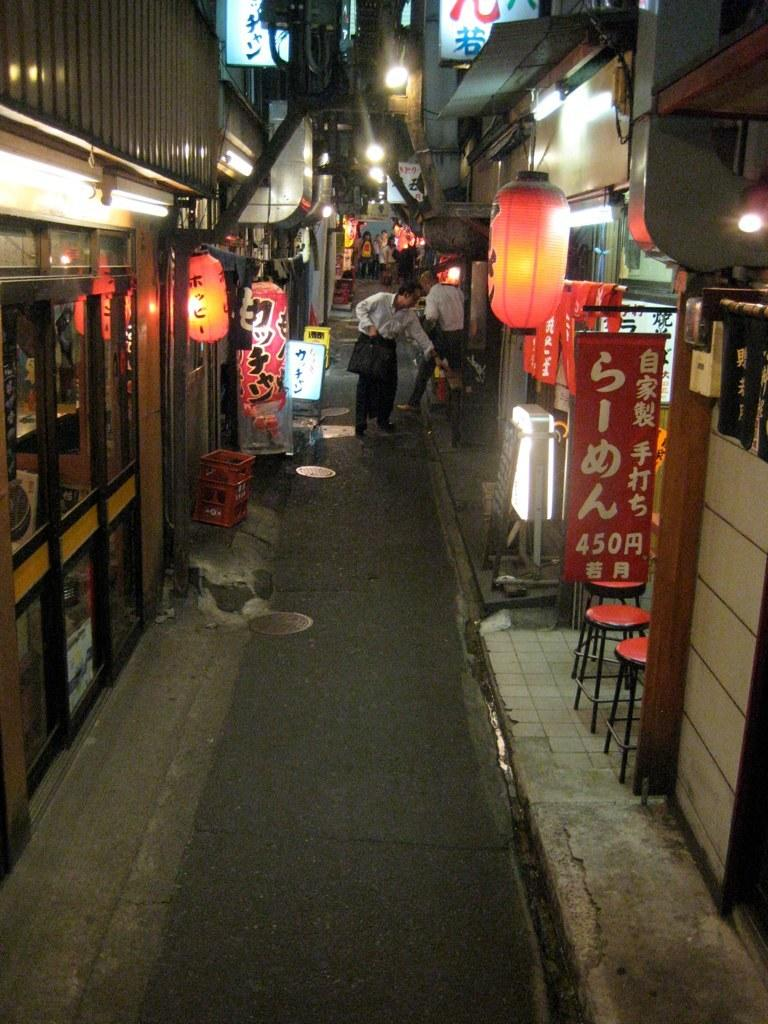What is happening on the road in the image? There are people on the road in the image. What can be seen in the distance behind the people? There are buildings, lights, poles, boxes, chairs, and banners in the background of the image. Are there any wires visible in the image? Yes, there are wires in the background of the image. How many eyes can be seen on the banners in the image? There are no eyes visible on the banners in the image. Can you tell me how many times the people in the image sneeze? There is no indication of anyone sneezing in the image. 